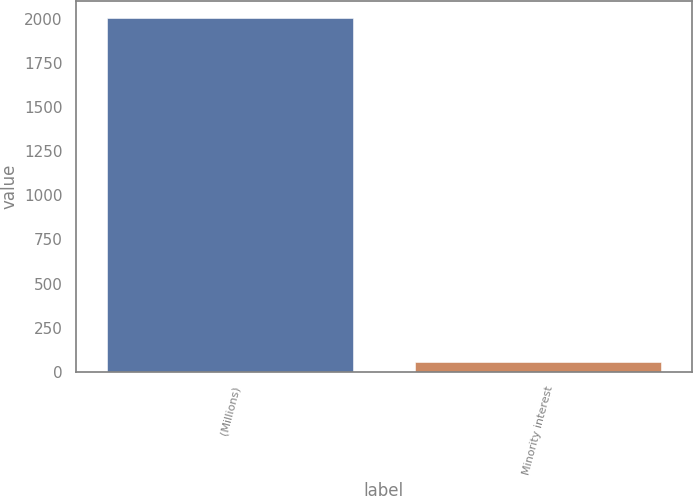Convert chart to OTSL. <chart><loc_0><loc_0><loc_500><loc_500><bar_chart><fcel>(Millions)<fcel>Minority interest<nl><fcel>2005<fcel>55<nl></chart> 